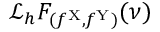<formula> <loc_0><loc_0><loc_500><loc_500>\mathcal { L } _ { h } F _ { ( f ^ { X } , f ^ { Y } ) } ( \nu )</formula> 